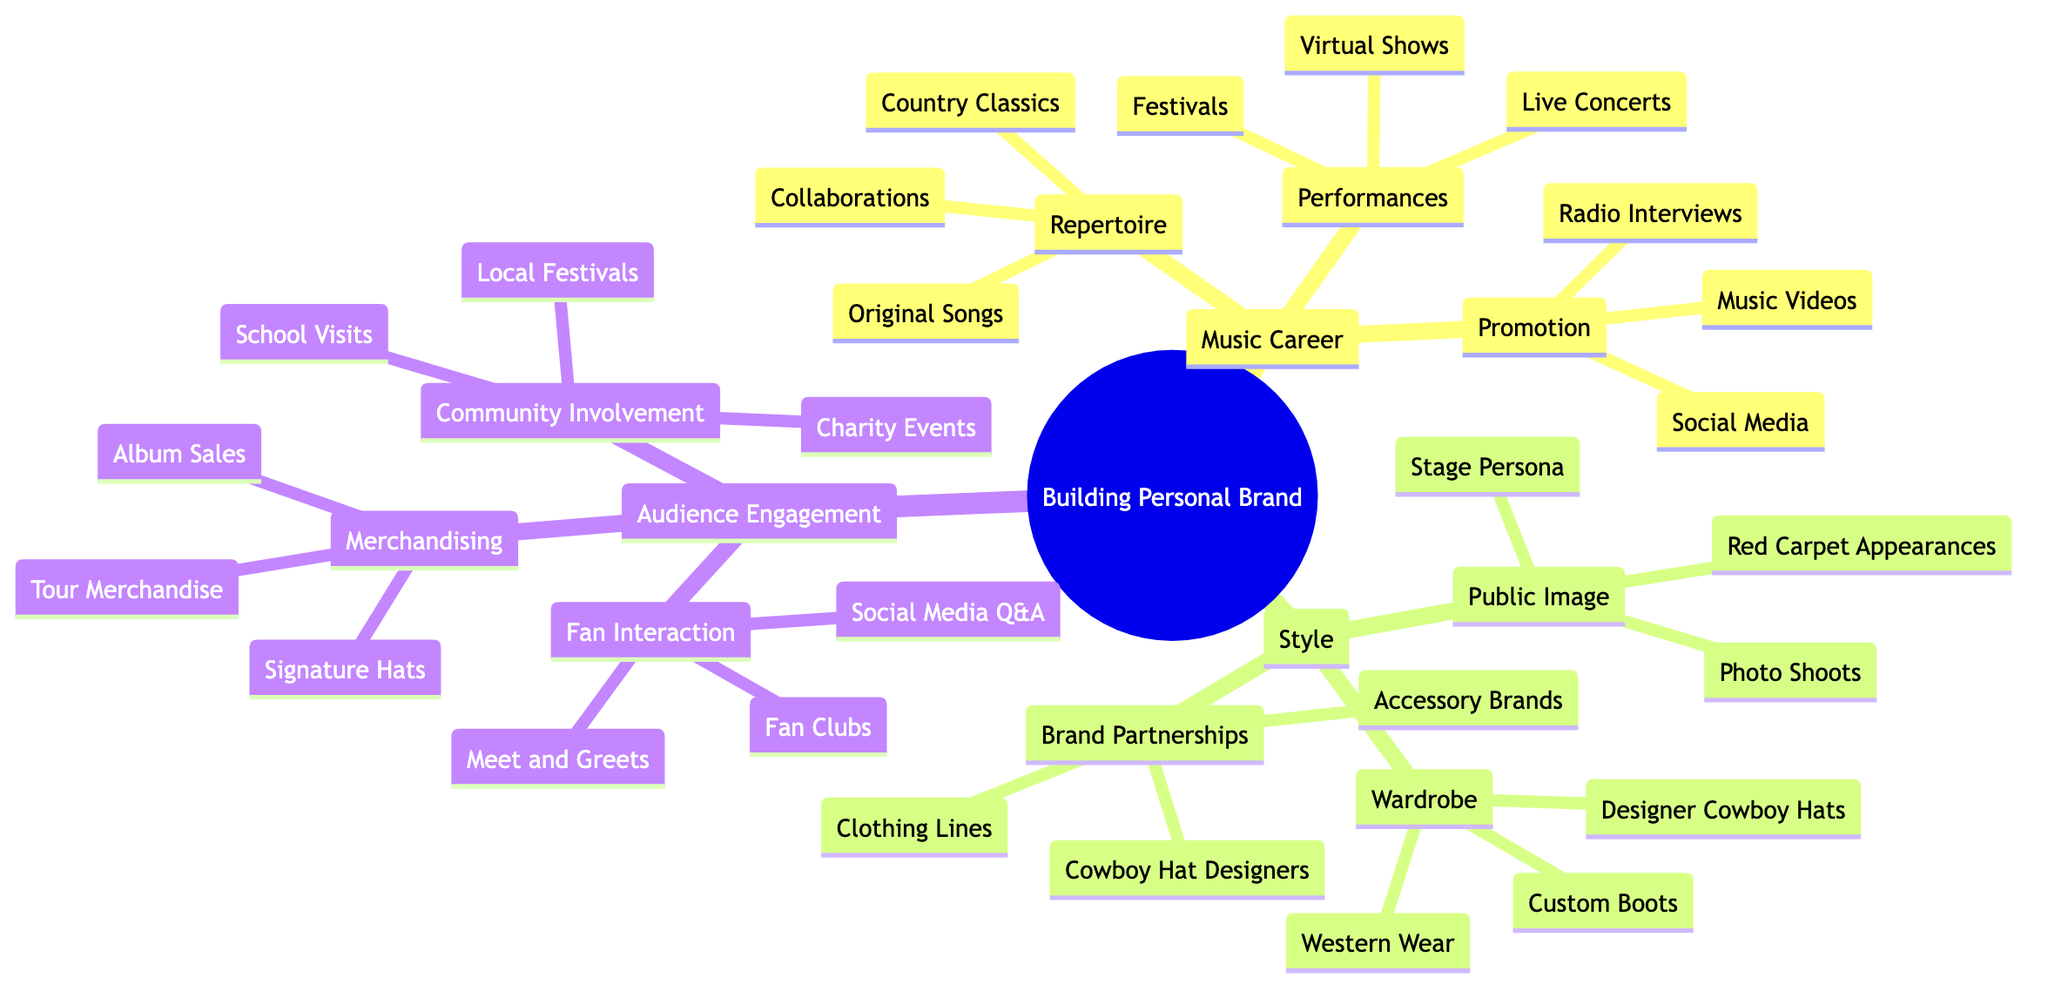What are the three types of repertoire in the music career section? The diagram lists three items under the "Repertoire" node in the "Music Career" section: Country Classics, Original Songs, and Collaborations with Other Artists.
Answer: Country Classics, Original Songs, Collaborations with Other Artists How many performance types are there in the music career? The "Performances" node in the "Music Career" section has three branches: Live Concerts, Festivals, and Virtual Shows, which means there are a total of three performance types.
Answer: 3 What type of wardrobe is featured in the style section? The diagram indicates three main items under the "Wardrobe" node in the "Style" section: Designer Cowboy Hats, Western Wear, and Custom Boots.
Answer: Designer Cowboy Hats, Western Wear, Custom Boots Which two aspects are included in the public image category? The "Public Image" node in the "Style" section lists three items: Stage Persona, Red Carpet Appearances, and Photo Shoots. However, the question asks for two aspects, so we can take any two of those items.
Answer: Stage Persona, Red Carpet Appearances What is the connection between community involvement and fan interaction? Both "Community Involvement" and "Fan Interaction" are branches under the broader category "Audience Engagement." This indicates that they are part of the same overarching theme of how the artist interacts with their audience.
Answer: They are both part of Audience Engagement What elements fall under brand partnerships? In the "Brand Partnerships" node from the "Style" section, there are three branches: Clothing Lines, Accessory Brands, and Cowboy Hat Designers, which details the elements involved in this aspect of building a personal brand.
Answer: Clothing Lines, Accessory Brands, Cowboy Hat Designers What are two ways to engage fans according to the diagram? The "Fan Interaction" node lists three items: Meet and Greets, Social Media Q&A, and Fan Clubs. For this question, any two of these items can be identified, thus they reflect the various engagement methods with fans.
Answer: Meet and Greets, Social Media Q&A Which section contains merch-related activities? The "Merchandising" node is listed under "Audience Engagement," indicating that this section addresses activities related to selling and promoting merchandise, including Signature Hats, Tour Merchandise, and Album Sales.
Answer: Audience Engagement 